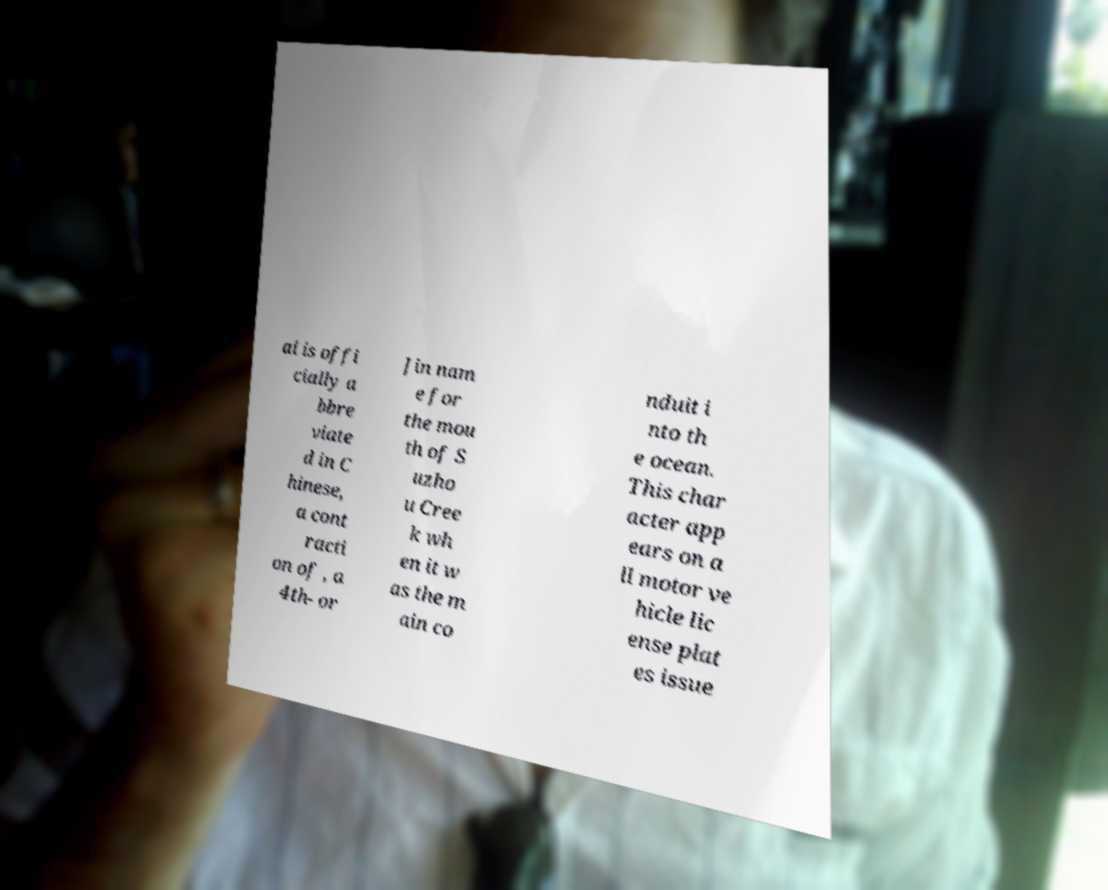Can you read and provide the text displayed in the image?This photo seems to have some interesting text. Can you extract and type it out for me? ai is offi cially a bbre viate d in C hinese, a cont racti on of , a 4th- or Jin nam e for the mou th of S uzho u Cree k wh en it w as the m ain co nduit i nto th e ocean. This char acter app ears on a ll motor ve hicle lic ense plat es issue 